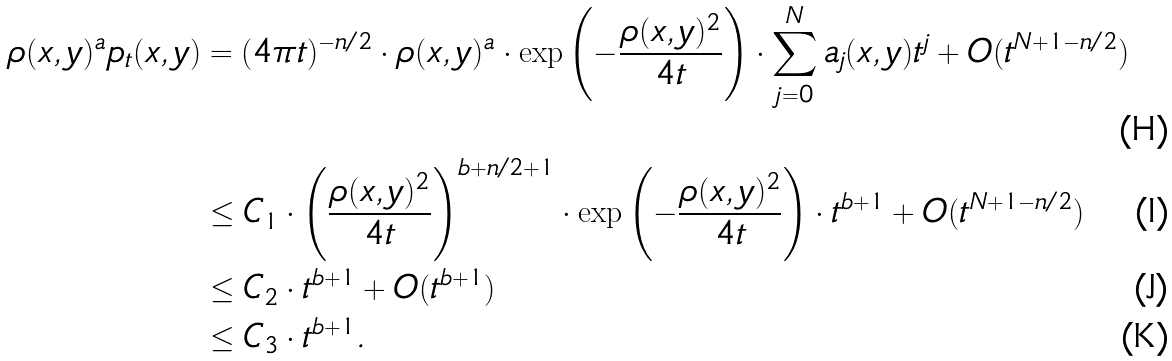<formula> <loc_0><loc_0><loc_500><loc_500>\rho ( x , y ) ^ { a } p _ { t } ( x , y ) & = ( 4 \pi t ) ^ { - n / 2 } \cdot \rho ( x , y ) ^ { a } \cdot \exp \left ( - \frac { \rho ( x , y ) ^ { 2 } } { 4 t } \right ) \cdot \sum _ { j = 0 } ^ { N } a _ { j } ( x , y ) t ^ { j } + O ( t ^ { N + 1 - n / 2 } ) \\ & \leq C _ { 1 } \cdot \left ( \frac { \rho ( x , y ) ^ { 2 } } { 4 t } \right ) ^ { b + n / 2 + 1 } \cdot \exp \left ( - \frac { \rho ( x , y ) ^ { 2 } } { 4 t } \right ) \cdot t ^ { b + 1 } + O ( t ^ { N + 1 - n / 2 } ) \\ & \leq C _ { 2 } \cdot t ^ { b + 1 } + O ( t ^ { b + 1 } ) \\ & \leq C _ { 3 } \cdot t ^ { b + 1 } .</formula> 